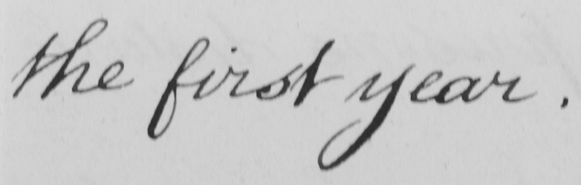What does this handwritten line say? the first year . 